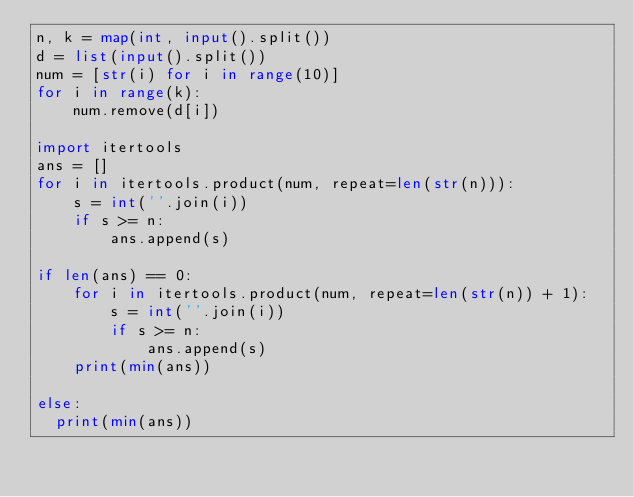Convert code to text. <code><loc_0><loc_0><loc_500><loc_500><_Python_>n, k = map(int, input().split())
d = list(input().split())
num = [str(i) for i in range(10)]
for i in range(k):
    num.remove(d[i])
    
import itertools
ans = []
for i in itertools.product(num, repeat=len(str(n))):
    s = int(''.join(i))
    if s >= n:
        ans.append(s)
        
if len(ans) == 0:
    for i in itertools.product(num, repeat=len(str(n)) + 1):
        s = int(''.join(i))
        if s >= n:
            ans.append(s)
    print(min(ans))
    
else:
  print(min(ans))</code> 